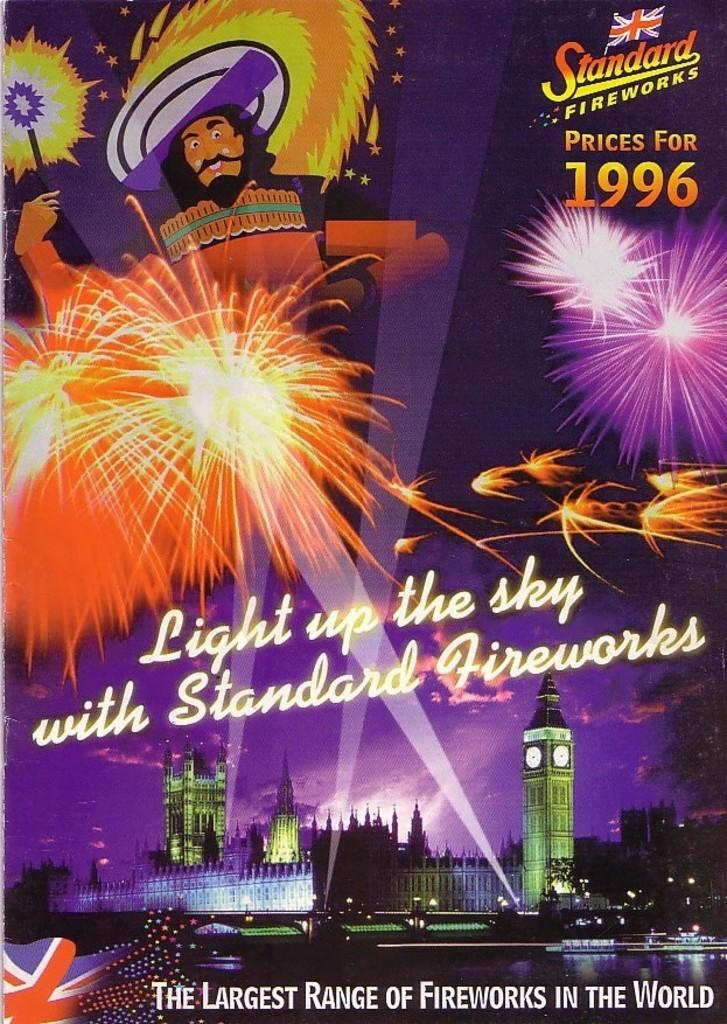<image>
Provide a brief description of the given image. Light up the sky with standard fireworks prices for 1996 